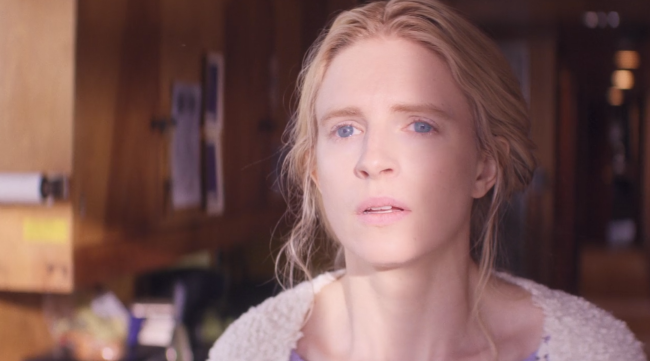Paint a detailed scenario based on this image. In a cozy mountain cabin, surrounded by serene nature, she returns to this secluded refuge to escape the chaos of city life. The wooden walls of the cabin, decorated with photos and knick-knacks from years past, tell stories of tranquil summers and quiet winters. She stands by the window, gazing out at the sunlit forest. Her soft white sweater adds to the sense of calm, making her look like a natural part of this peaceful scene. Her serene but contemplative expression suggests she is reflecting on her journey, the bumps along the road and everything that brought her back to this place of solace. As she delves into her thoughts, the vivid memories come flooding back – the laughter, the tears, and the moments of solitude that only this place has witnessed. 